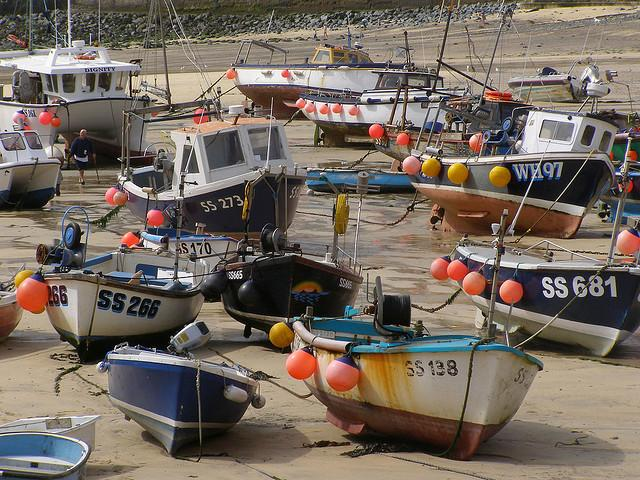What boat number is the largest here? 681 